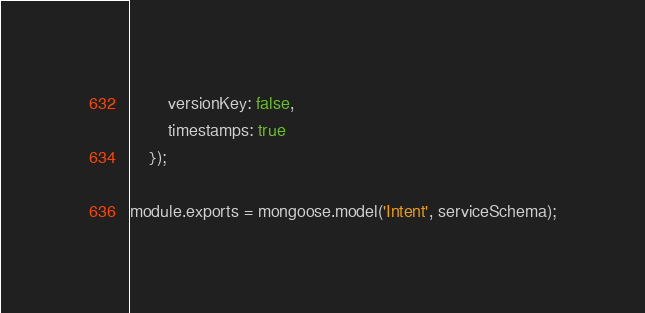Convert code to text. <code><loc_0><loc_0><loc_500><loc_500><_JavaScript_>        versionKey: false,
        timestamps: true
    });

module.exports = mongoose.model('Intent', serviceSchema);</code> 